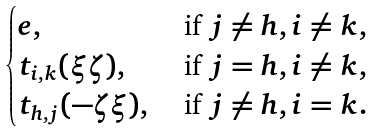Convert formula to latex. <formula><loc_0><loc_0><loc_500><loc_500>\begin{cases} e , & \text { if } j \neq h , i \neq k , \\ t _ { i , k } ( \xi \zeta ) , & \text { if } j = h , i \neq k , \\ t _ { h , j } ( - \zeta \xi ) , & \text { if } j \neq h , i = k . \end{cases}</formula> 